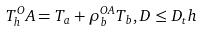Convert formula to latex. <formula><loc_0><loc_0><loc_500><loc_500>T _ { h } ^ { O } A = T _ { a } + \rho _ { b } ^ { O A } T _ { b } , D \leq D _ { t } h</formula> 